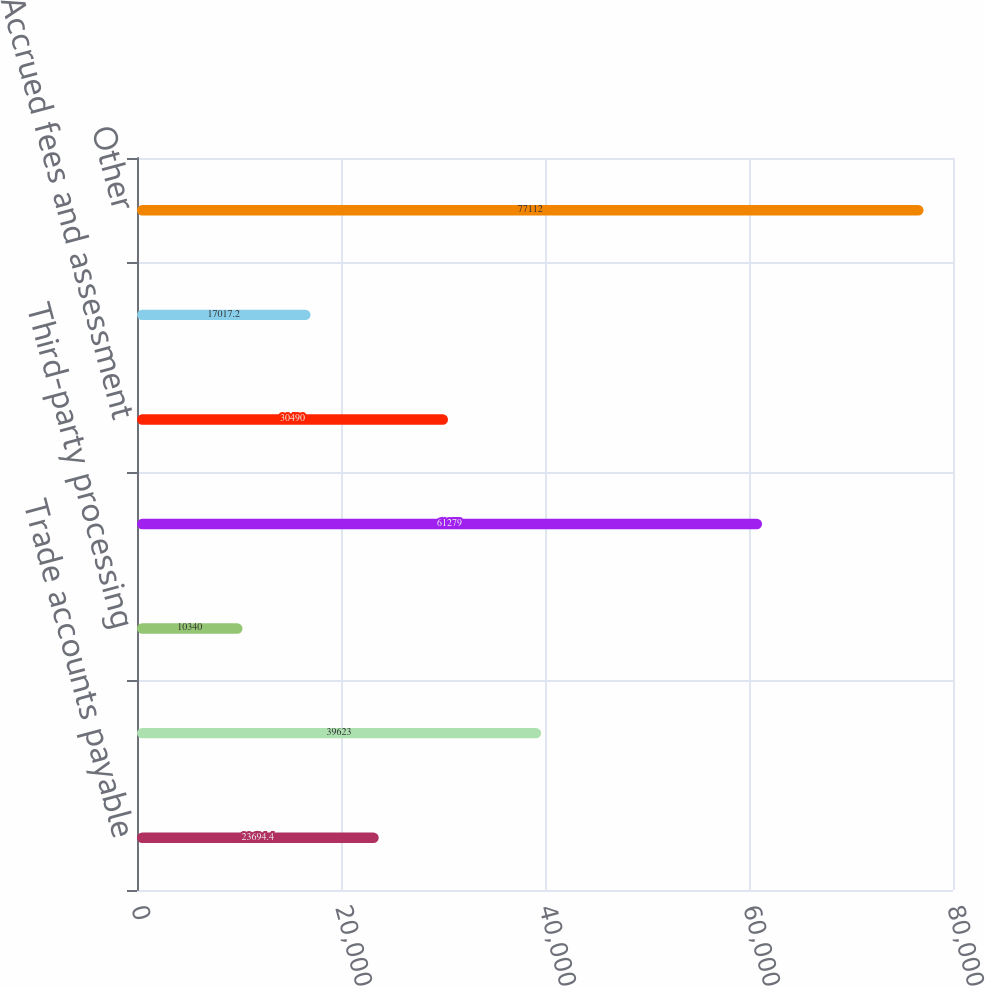<chart> <loc_0><loc_0><loc_500><loc_500><bar_chart><fcel>Trade accounts payable<fcel>Compensation and benefits<fcel>Third-party processing<fcel>Commissions to third parties<fcel>Accrued fees and assessment<fcel>Transition service fees<fcel>Other<nl><fcel>23694.4<fcel>39623<fcel>10340<fcel>61279<fcel>30490<fcel>17017.2<fcel>77112<nl></chart> 